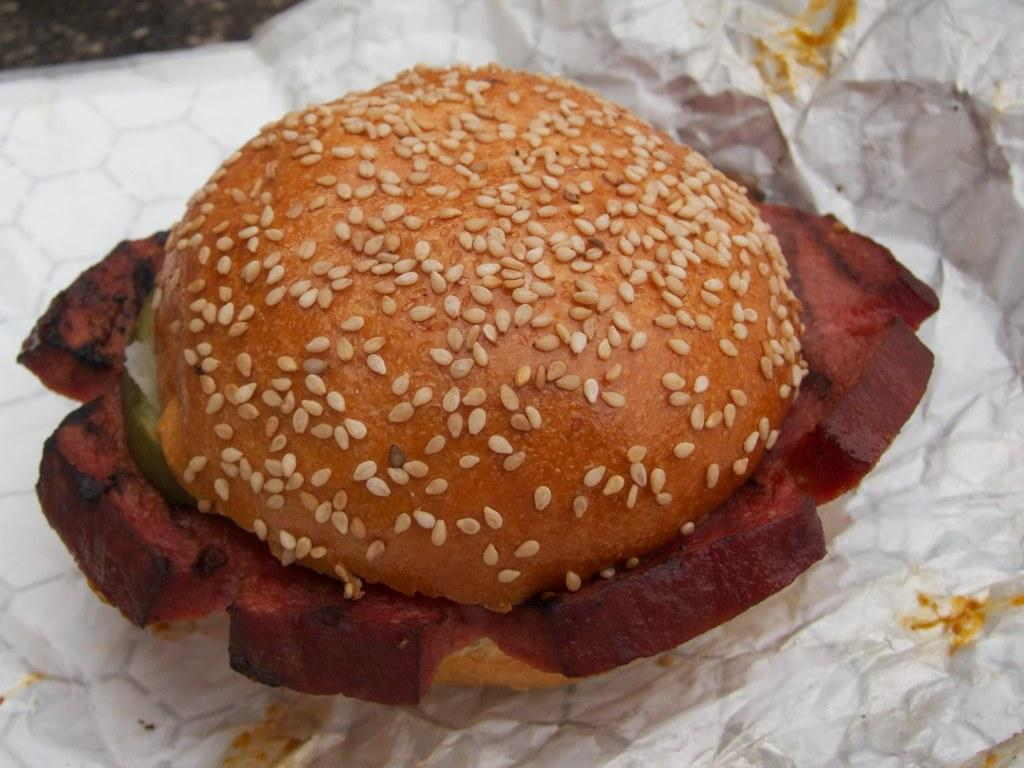What type of food is visible in the image? There is a burger in the image. What is the burger placed on? The burger is placed on a paper. Can you see any ghosts interacting with the burger in the image? There are no ghosts present in the image, and therefore no such interaction can be observed. 